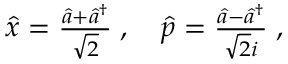Convert formula to latex. <formula><loc_0><loc_0><loc_500><loc_500>\begin{array} { r } { \hat { x } = \frac { \hat { a } + \hat { a } ^ { \dagger } } { \sqrt { 2 } } \, , \quad \hat { p } = \frac { \hat { a } - \hat { a } ^ { \dagger } } { \sqrt { 2 } i } \, , } \end{array}</formula> 